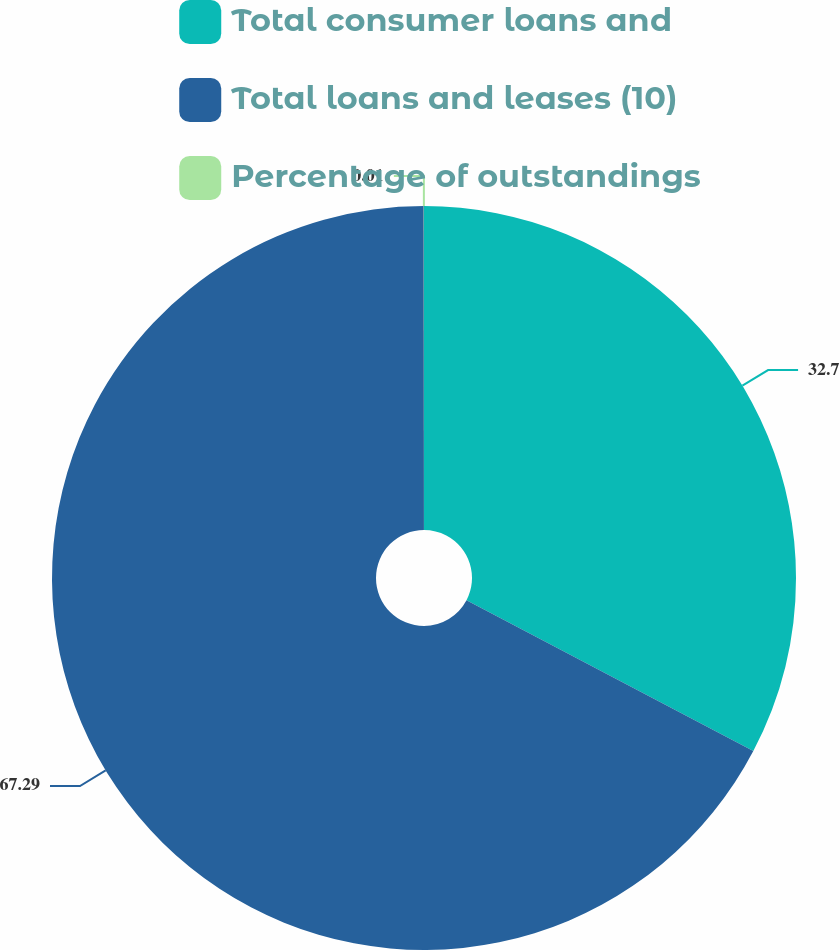Convert chart. <chart><loc_0><loc_0><loc_500><loc_500><pie_chart><fcel>Total consumer loans and<fcel>Total loans and leases (10)<fcel>Percentage of outstandings<nl><fcel>32.7%<fcel>67.29%<fcel>0.01%<nl></chart> 